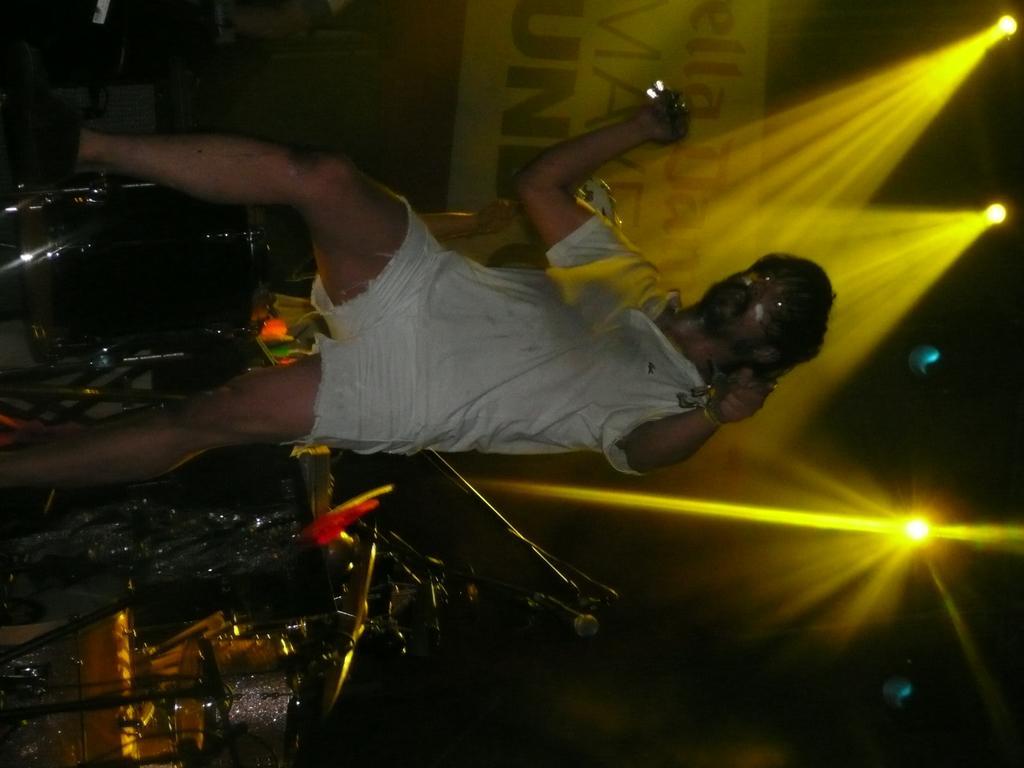In one or two sentences, can you explain what this image depicts? In this image we can see a person holding an object in his hand is standing. In the background, we can see some musical instruments. In the right side of the image we can some lights. At the top of the image we can see a banner with some text. 